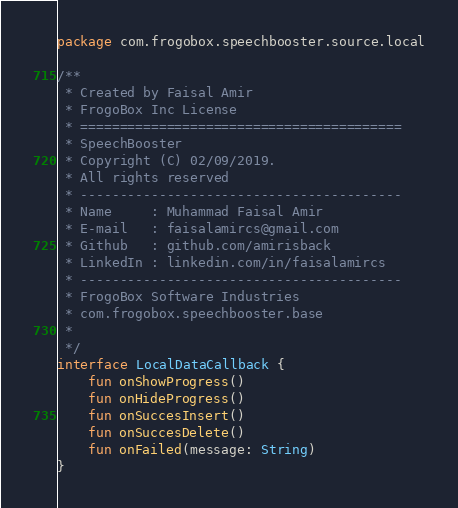Convert code to text. <code><loc_0><loc_0><loc_500><loc_500><_Kotlin_>package com.frogobox.speechbooster.source.local

/**
 * Created by Faisal Amir
 * FrogoBox Inc License
 * =========================================
 * SpeechBooster
 * Copyright (C) 02/09/2019.
 * All rights reserved
 * -----------------------------------------
 * Name     : Muhammad Faisal Amir
 * E-mail   : faisalamircs@gmail.com
 * Github   : github.com/amirisback
 * LinkedIn : linkedin.com/in/faisalamircs
 * -----------------------------------------
 * FrogoBox Software Industries
 * com.frogobox.speechbooster.base
 *
 */
interface LocalDataCallback {
    fun onShowProgress()
    fun onHideProgress()
    fun onSuccesInsert()
    fun onSuccesDelete()
    fun onFailed(message: String)
}</code> 